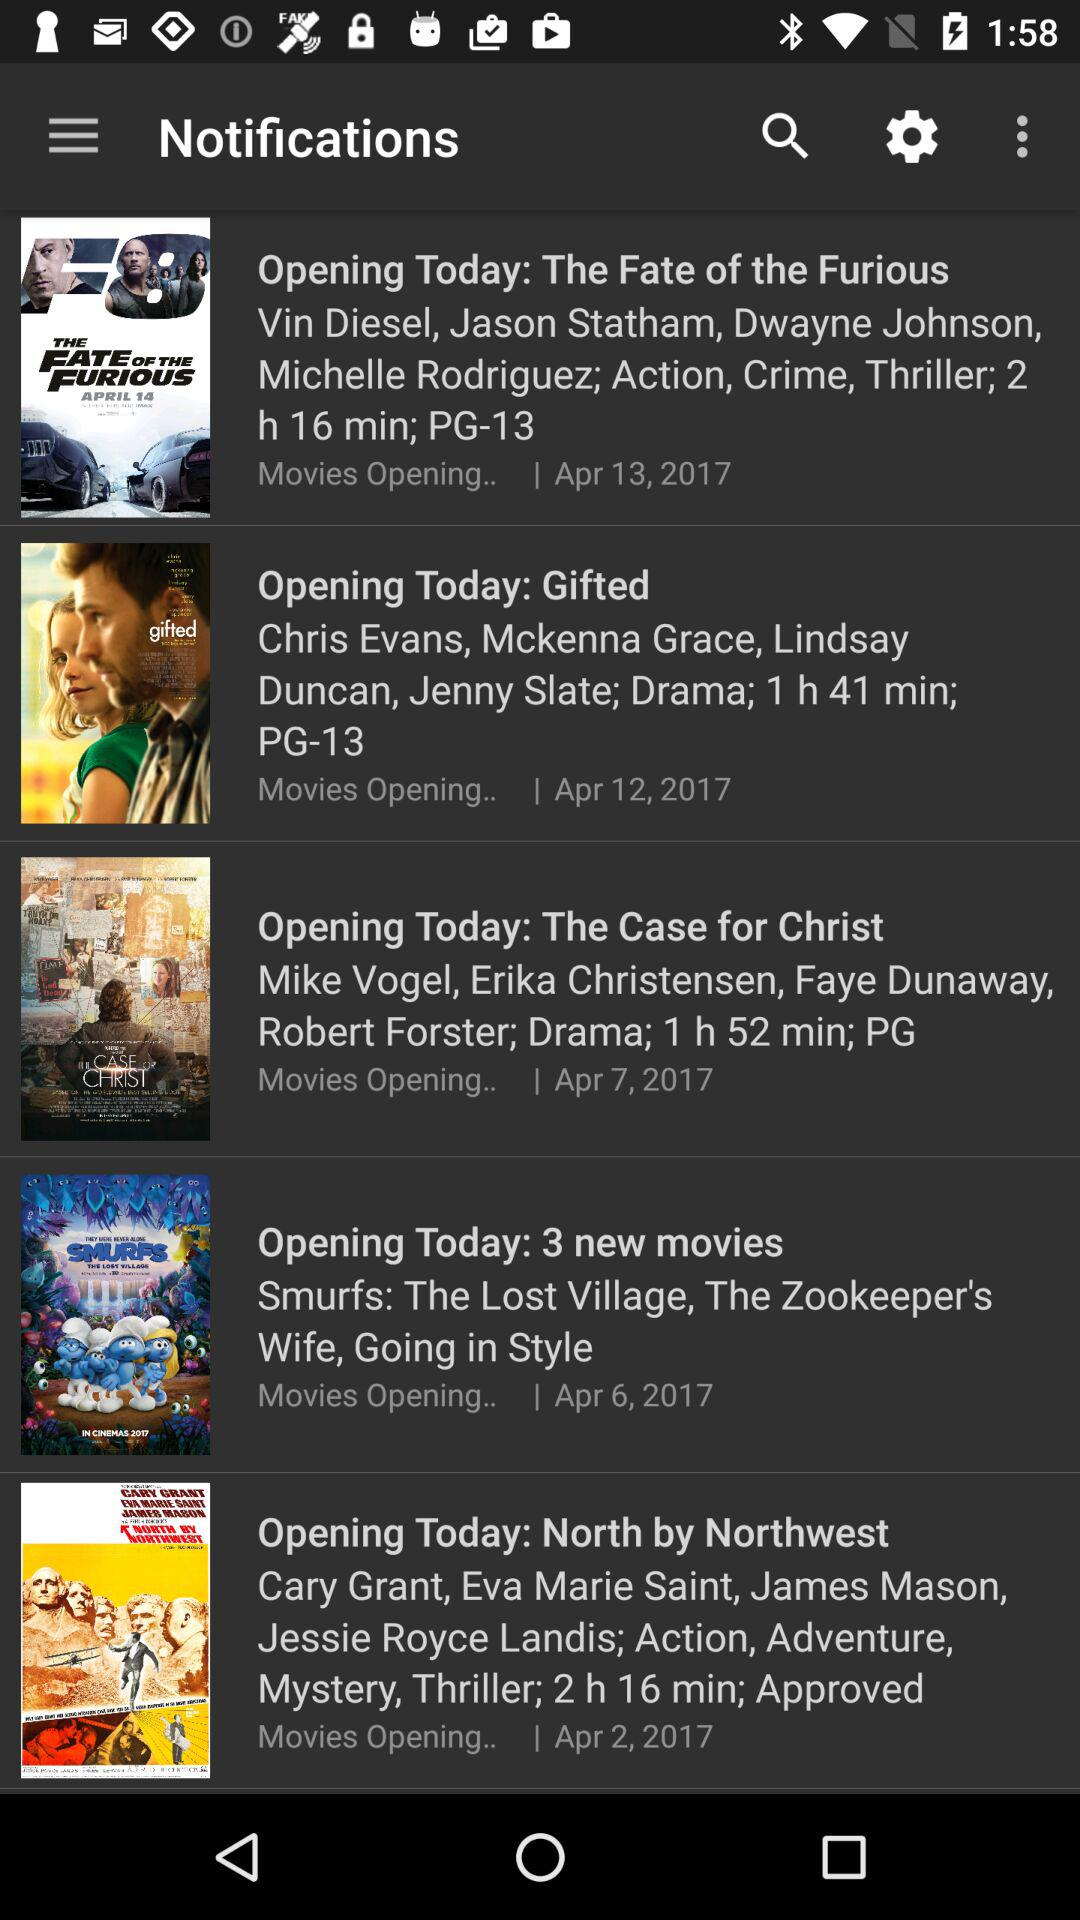What is the duration of "The Fate of the Furious" movie? The duration of "The Fate of the Furious" movie is 2 hours 16 minutes. 